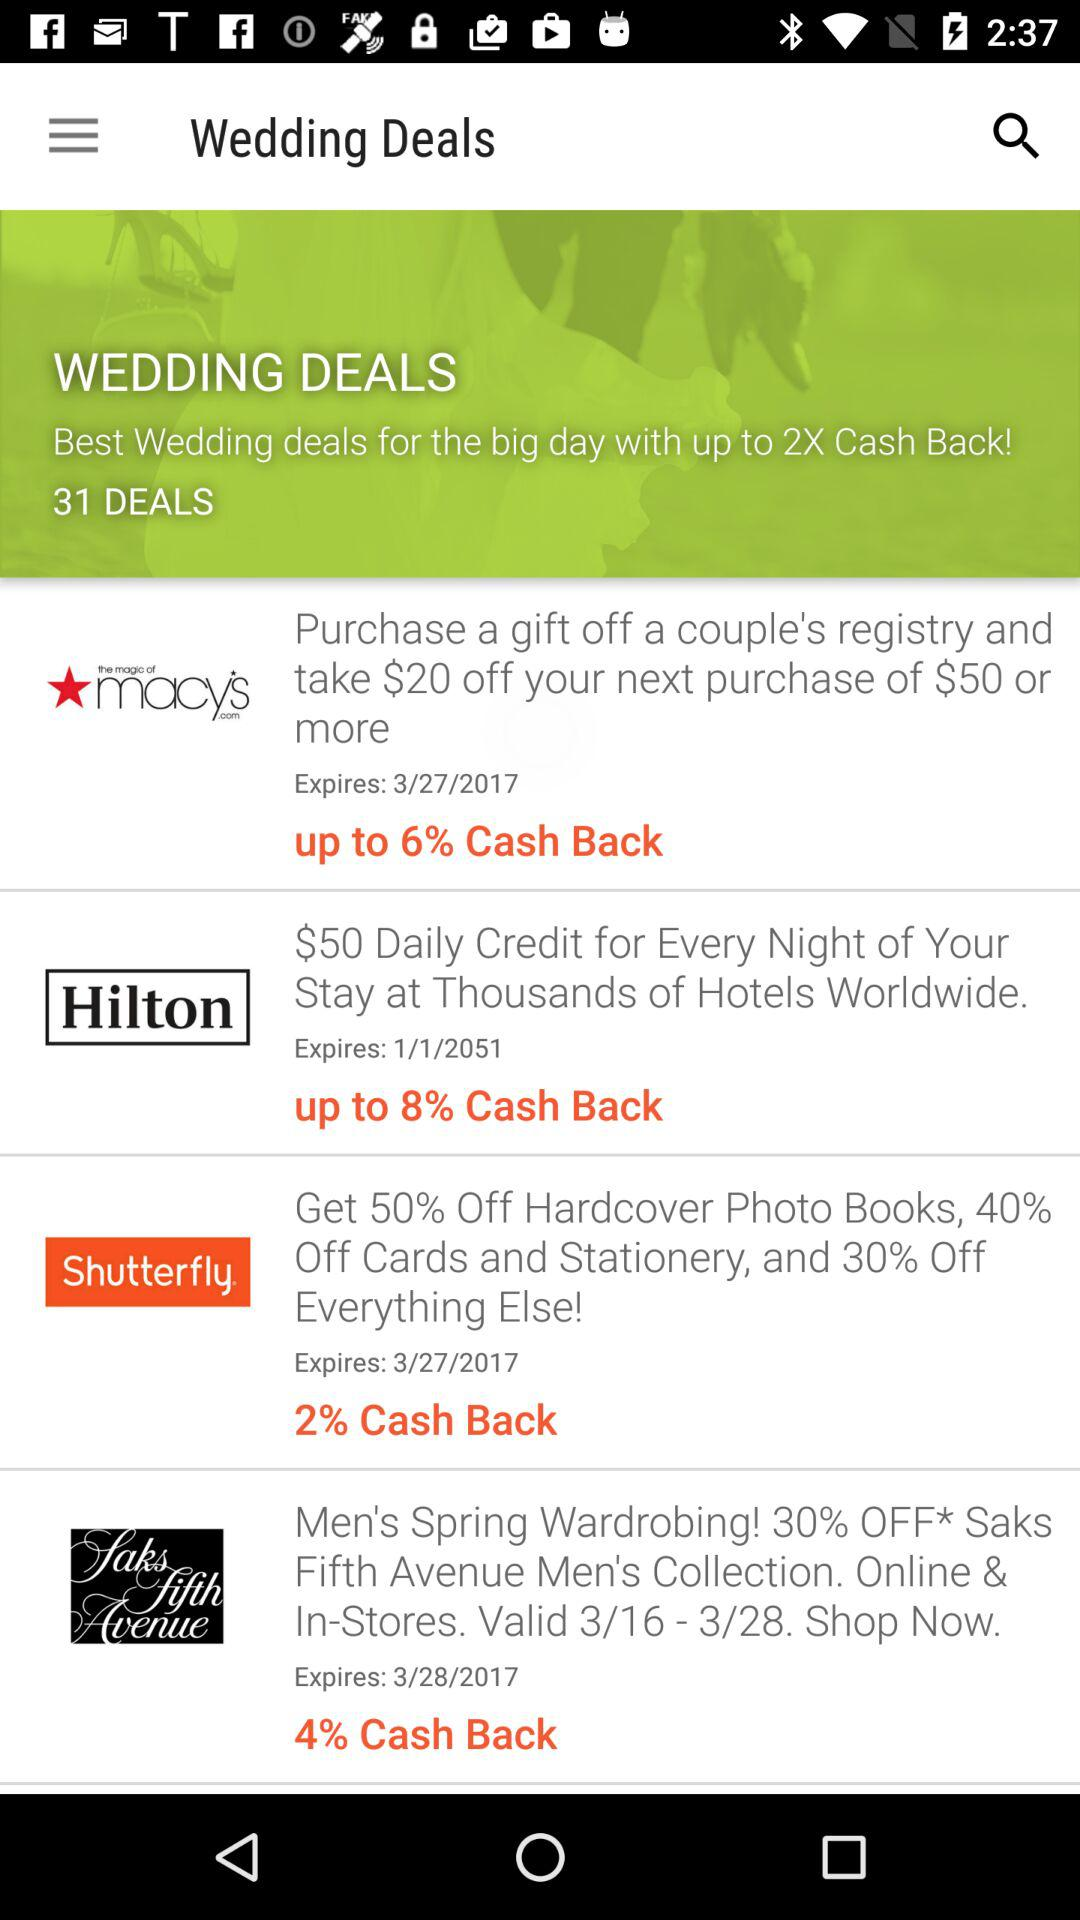Up to how much cashback is given on the Hilton coupon? The cashback is up to 8%. 